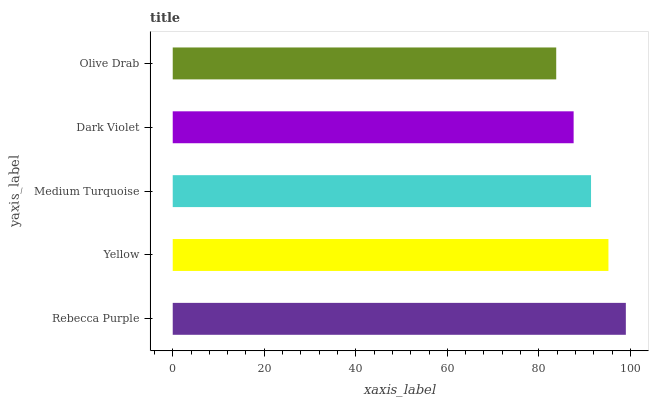Is Olive Drab the minimum?
Answer yes or no. Yes. Is Rebecca Purple the maximum?
Answer yes or no. Yes. Is Yellow the minimum?
Answer yes or no. No. Is Yellow the maximum?
Answer yes or no. No. Is Rebecca Purple greater than Yellow?
Answer yes or no. Yes. Is Yellow less than Rebecca Purple?
Answer yes or no. Yes. Is Yellow greater than Rebecca Purple?
Answer yes or no. No. Is Rebecca Purple less than Yellow?
Answer yes or no. No. Is Medium Turquoise the high median?
Answer yes or no. Yes. Is Medium Turquoise the low median?
Answer yes or no. Yes. Is Dark Violet the high median?
Answer yes or no. No. Is Yellow the low median?
Answer yes or no. No. 